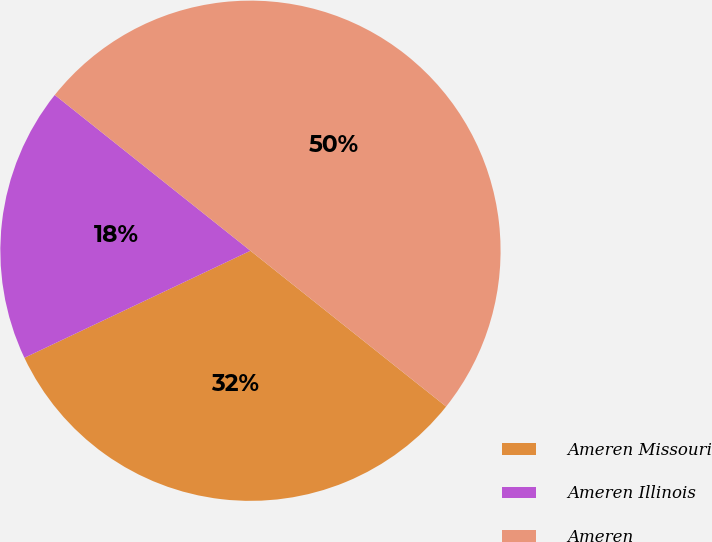Convert chart. <chart><loc_0><loc_0><loc_500><loc_500><pie_chart><fcel>Ameren Missouri<fcel>Ameren Illinois<fcel>Ameren<nl><fcel>32.26%<fcel>17.74%<fcel>50.0%<nl></chart> 